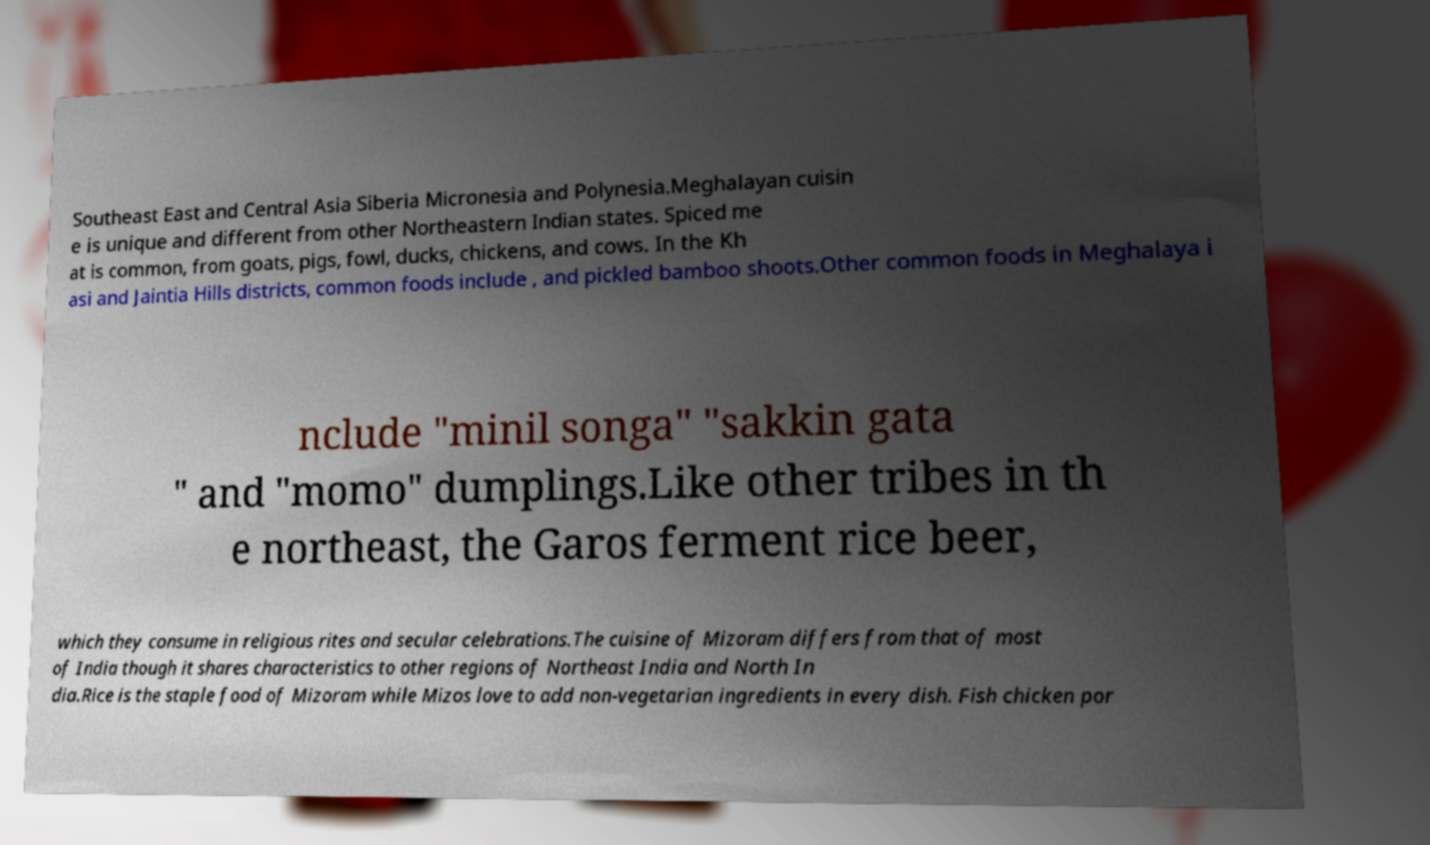Can you accurately transcribe the text from the provided image for me? Southeast East and Central Asia Siberia Micronesia and Polynesia.Meghalayan cuisin e is unique and different from other Northeastern Indian states. Spiced me at is common, from goats, pigs, fowl, ducks, chickens, and cows. In the Kh asi and Jaintia Hills districts, common foods include , and pickled bamboo shoots.Other common foods in Meghalaya i nclude "minil songa" "sakkin gata " and "momo" dumplings.Like other tribes in th e northeast, the Garos ferment rice beer, which they consume in religious rites and secular celebrations.The cuisine of Mizoram differs from that of most of India though it shares characteristics to other regions of Northeast India and North In dia.Rice is the staple food of Mizoram while Mizos love to add non-vegetarian ingredients in every dish. Fish chicken por 